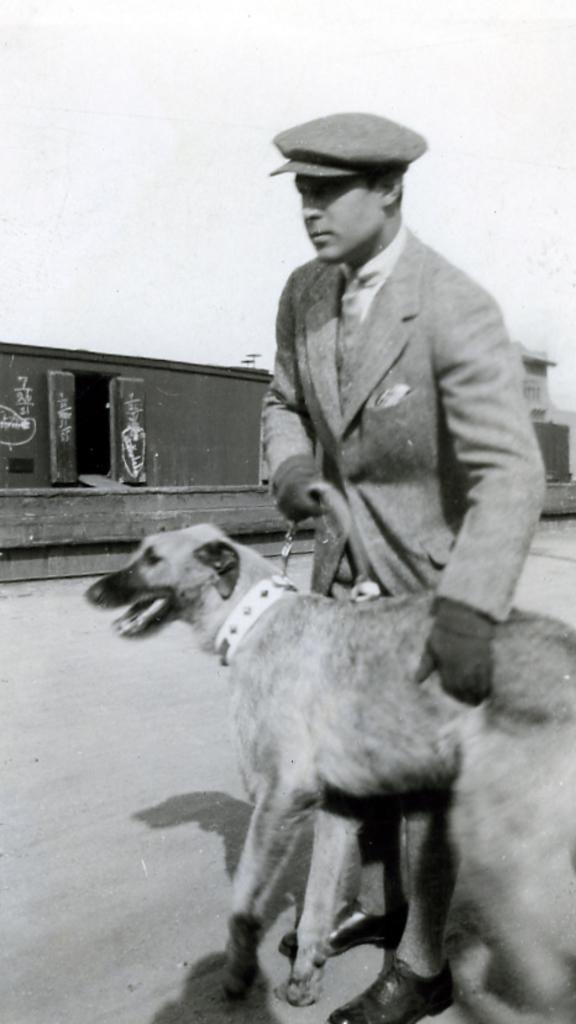In one or two sentences, can you explain what this image depicts? This is black and white picture. He is in suite and he wear a cap. He is holding a dog with his hand. And this is road. 